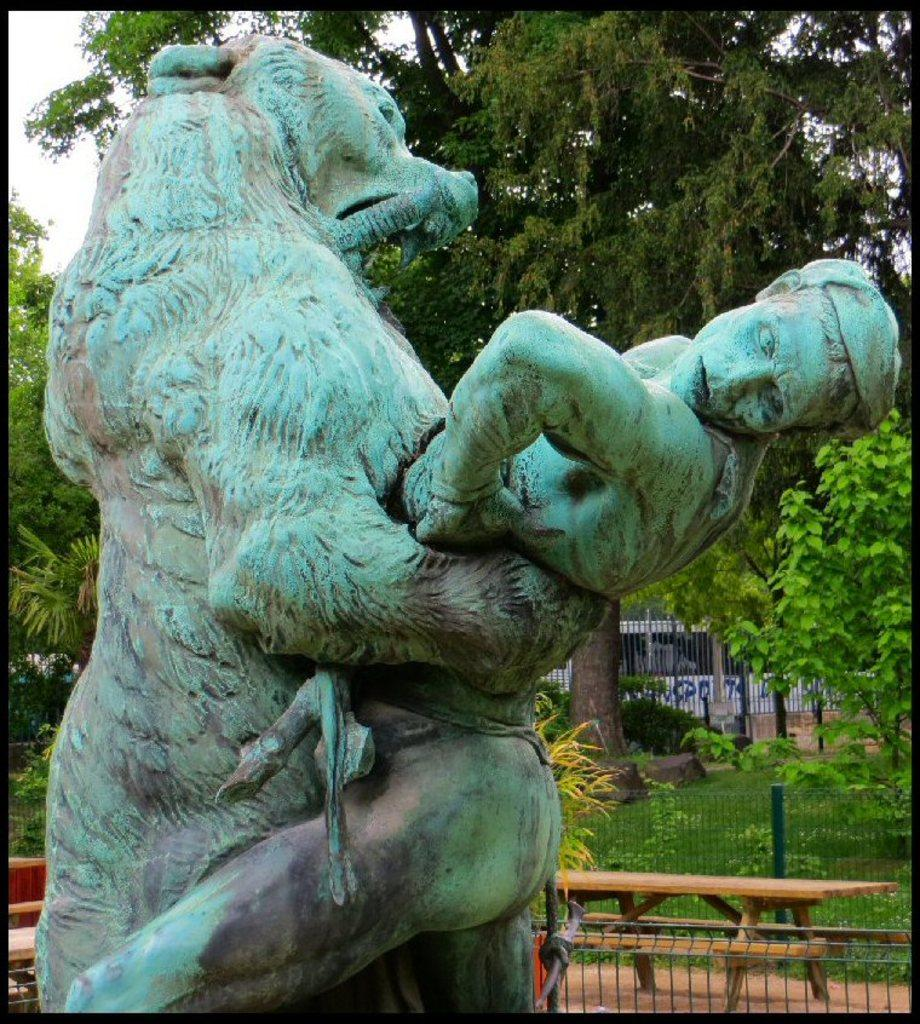What types of statues are present in the image? There is a statue of an animal and a statue of a human in the image. What type of seating is available in the image? There is a brown bench in the image. What other furniture is present in the image? There is a table on the ground in the image. What can be seen in the background of the image? There are trees and the sky visible in the background of the image. What type of cheese is being served on the table in the image? There is no cheese present in the image; it only features statues, a bench, and a table. How many toes are visible on the statue of the human in the image? The image does not show the toes of the statue of the human, so it cannot be determined from the image. 